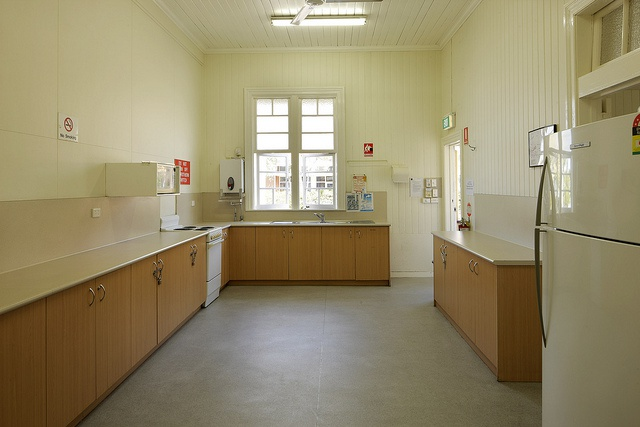Describe the objects in this image and their specific colors. I can see refrigerator in tan, gray, and darkgray tones, microwave in tan, darkgray, and lightgray tones, oven in tan, darkgray, gray, and lightgray tones, clock in tan, darkgray, lightgray, and gray tones, and sink in tan, gray, and olive tones in this image. 